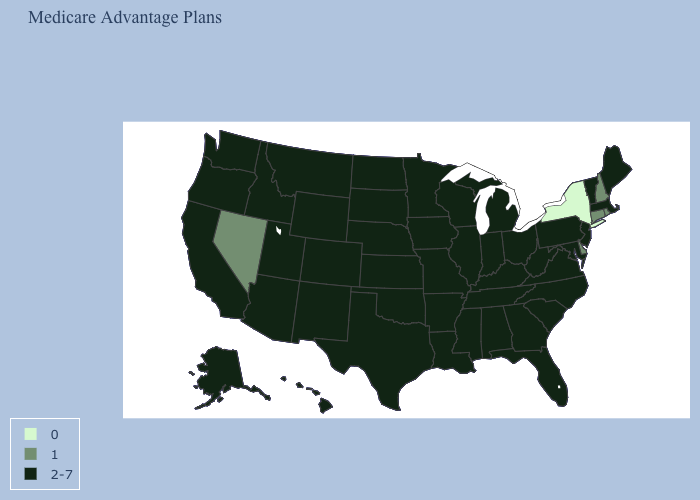Name the states that have a value in the range 1?
Short answer required. Connecticut, Delaware, New Hampshire, Nevada, Rhode Island. Among the states that border Pennsylvania , does Maryland have the highest value?
Answer briefly. Yes. Which states have the lowest value in the USA?
Give a very brief answer. New York. Name the states that have a value in the range 0?
Answer briefly. New York. What is the value of Tennessee?
Keep it brief. 2-7. Does New Hampshire have the highest value in the Northeast?
Short answer required. No. Does Delaware have the highest value in the South?
Give a very brief answer. No. Does Florida have the lowest value in the South?
Keep it brief. No. What is the highest value in states that border Idaho?
Be succinct. 2-7. What is the value of Illinois?
Be succinct. 2-7. What is the value of Connecticut?
Give a very brief answer. 1. What is the highest value in states that border Indiana?
Short answer required. 2-7. Does the first symbol in the legend represent the smallest category?
Answer briefly. Yes. Among the states that border Vermont , which have the highest value?
Quick response, please. Massachusetts. 